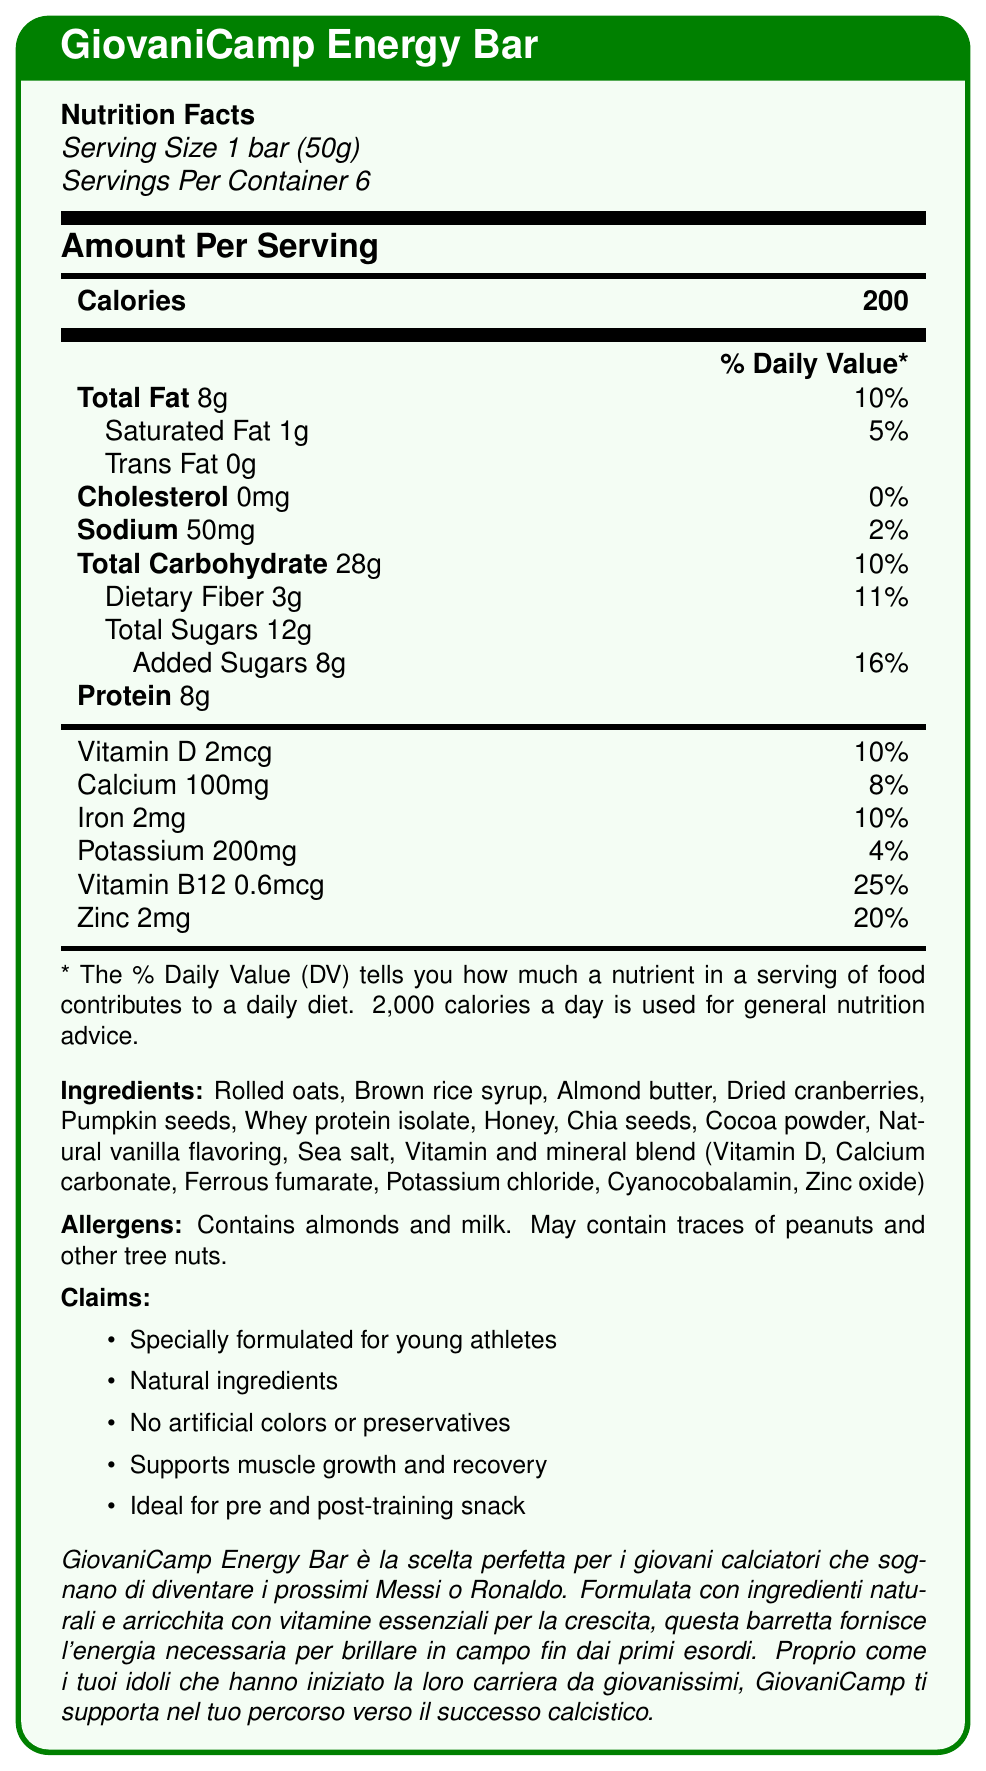How many calories are in one serving of GiovaniCamp Energy Bar? The document states that there are 200 calories per serving.
Answer: 200 How much protein is in one GiovaniCamp Energy Bar? The document lists the protein content as 8g per serving.
Answer: 8g What is the serving size for GiovaniCamp Energy Bar? The serving size is specified as 1 bar, which is 50 grams.
Answer: 1 bar (50g) How many servings are there in a container of GiovaniCamp Energy Bar? The document states there are 6 servings per container.
Answer: 6 Which vitamin in GiovaniCamp Energy Bar has the highest % Daily Value? The % Daily Value for Vitamin B12 is 25%, which is the highest amongst the listed vitamins and minerals.
Answer: Vitamin B12 How much total fat is in each serving? The document specifies that each bar contains 8g of total fat.
Answer: 8g GiovaniCamp Energy Bar is ideal for which of the following?  
A. On-the-go breakfast  
B. Pre and post-training snack  
C. Dinner dessert The document mentions that GiovaniCamp Energy Bar is ideal for a pre and post-training snack.
Answer: B Which of the following ingredients is NOT present in GiovaniCamp Energy Bar?  
A. Rolled oats  
B. Almond butter  
C. Granola The ingredients list includes rolled oats and almond butter, but not granola.
Answer: C Does GiovaniCamp Energy Bar contain any almonds? The document mentions almond butter as an ingredient and lists almonds in the allergens section.
Answer: Yes Can the total amount of added sugars in the entire container of GiovaniCamp Energy Bars be determined from the document? Each serving contains 8g of added sugars, and there are 6 servings per container, which totals 48g of added sugars.
Answer: Yes Does GiovaniCamp Energy Bar contain any artificial colors or preservatives? The claims section specifically states "No artificial colors or preservatives".
Answer: No Does GiovaniCamp Energy Bar support muscle growth and recovery? One of the claims is that the bar supports muscle growth and recovery.
Answer: Yes What is the main purpose of GiovaniCamp Energy Bar according to the marketing copy? The marketing copy emphasizes that the bar is designed to support young football players by providing energy and essential nutrients for their growth and performance, aligning their dreams with those of famous footballers.
Answer: To provide energy and essential vitamins for young football players for growth and effective performance How much potassium is in one GiovaniCamp Energy Bar? The document lists the potassium content as 200mg per serving.
Answer: 200mg Can we determine the exact number of peanuts in GiovaniCamp Energy Bar from the document? The document only mentions that it may contain traces of peanuts and other tree nuts, but does not specify the exact quantity.
Answer: Not enough information 